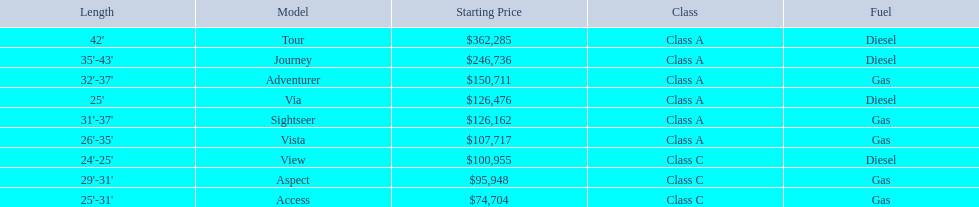What are all of the winnebago models? Tour, Journey, Adventurer, Via, Sightseer, Vista, View, Aspect, Access. What are their prices? $362,285, $246,736, $150,711, $126,476, $126,162, $107,717, $100,955, $95,948, $74,704. And which model costs the most? Tour. 